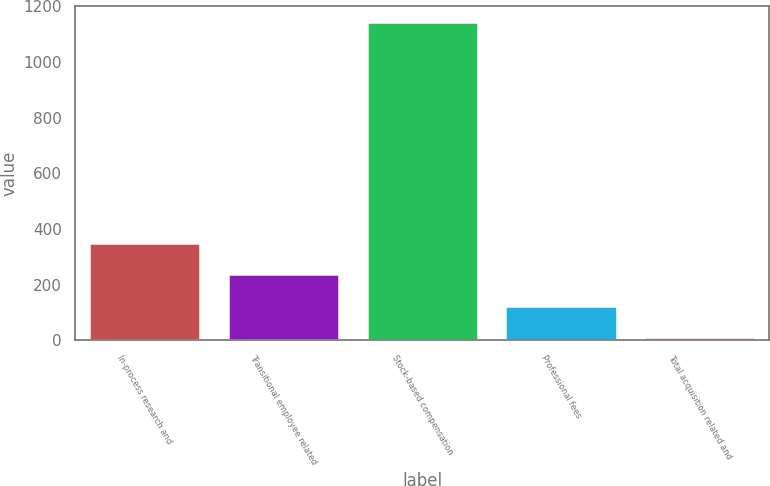Convert chart to OTSL. <chart><loc_0><loc_0><loc_500><loc_500><bar_chart><fcel>In-process research and<fcel>Transitional employee related<fcel>Stock-based compensation<fcel>Professional fees<fcel>Total acquisition related and<nl><fcel>350.9<fcel>237.6<fcel>1144<fcel>124.3<fcel>11<nl></chart> 